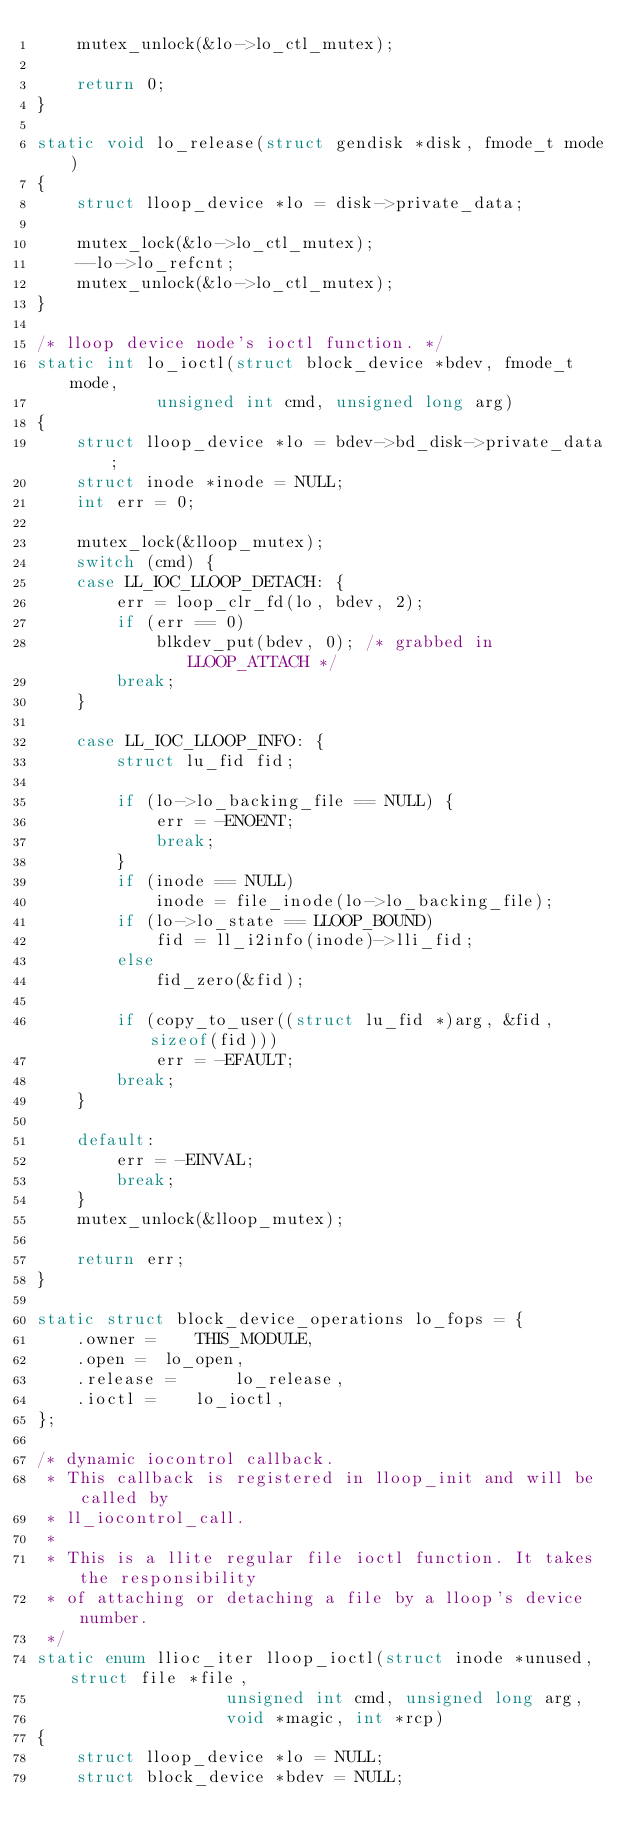Convert code to text. <code><loc_0><loc_0><loc_500><loc_500><_C_>	mutex_unlock(&lo->lo_ctl_mutex);

	return 0;
}

static void lo_release(struct gendisk *disk, fmode_t mode)
{
	struct lloop_device *lo = disk->private_data;

	mutex_lock(&lo->lo_ctl_mutex);
	--lo->lo_refcnt;
	mutex_unlock(&lo->lo_ctl_mutex);
}

/* lloop device node's ioctl function. */
static int lo_ioctl(struct block_device *bdev, fmode_t mode,
		    unsigned int cmd, unsigned long arg)
{
	struct lloop_device *lo = bdev->bd_disk->private_data;
	struct inode *inode = NULL;
	int err = 0;

	mutex_lock(&lloop_mutex);
	switch (cmd) {
	case LL_IOC_LLOOP_DETACH: {
		err = loop_clr_fd(lo, bdev, 2);
		if (err == 0)
			blkdev_put(bdev, 0); /* grabbed in LLOOP_ATTACH */
		break;
	}

	case LL_IOC_LLOOP_INFO: {
		struct lu_fid fid;

		if (lo->lo_backing_file == NULL) {
			err = -ENOENT;
			break;
		}
		if (inode == NULL)
			inode = file_inode(lo->lo_backing_file);
		if (lo->lo_state == LLOOP_BOUND)
			fid = ll_i2info(inode)->lli_fid;
		else
			fid_zero(&fid);

		if (copy_to_user((struct lu_fid *)arg, &fid, sizeof(fid)))
			err = -EFAULT;
		break;
	}

	default:
		err = -EINVAL;
		break;
	}
	mutex_unlock(&lloop_mutex);

	return err;
}

static struct block_device_operations lo_fops = {
	.owner =	THIS_MODULE,
	.open =	 lo_open,
	.release =      lo_release,
	.ioctl =	lo_ioctl,
};

/* dynamic iocontrol callback.
 * This callback is registered in lloop_init and will be called by
 * ll_iocontrol_call.
 *
 * This is a llite regular file ioctl function. It takes the responsibility
 * of attaching or detaching a file by a lloop's device number.
 */
static enum llioc_iter lloop_ioctl(struct inode *unused, struct file *file,
				   unsigned int cmd, unsigned long arg,
				   void *magic, int *rcp)
{
	struct lloop_device *lo = NULL;
	struct block_device *bdev = NULL;</code> 